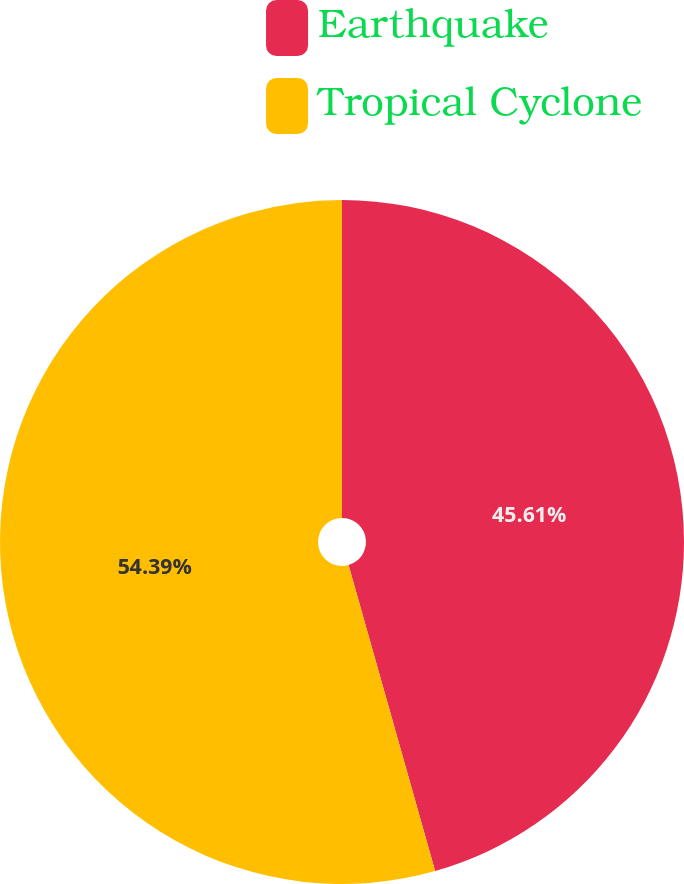Convert chart to OTSL. <chart><loc_0><loc_0><loc_500><loc_500><pie_chart><fcel>Earthquake<fcel>Tropical Cyclone<nl><fcel>45.61%<fcel>54.39%<nl></chart> 